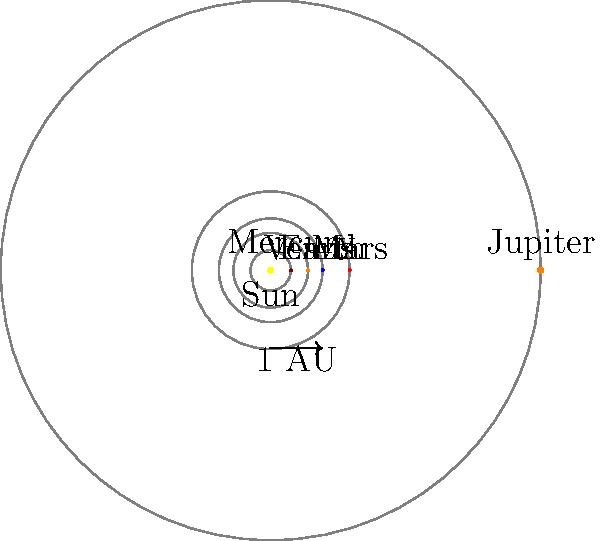Given your expertise in cancer research and data analysis, consider the following astronomical question:

The diagram shows a simplified model of the inner Solar System and Jupiter. If the average orbital radius of Earth is defined as 1 Astronomical Unit (AU), what is the approximate orbital radius of Jupiter in AU, and how does this relate to the concept of "zones" in the Solar System? To answer this question, we'll follow these steps:

1. Analyze the diagram:
   - The orbits are represented by concentric circles.
   - Earth's orbit is labeled and defined as 1 AU.
   - Jupiter's orbit is the outermost circle shown.

2. Estimate Jupiter's orbital radius:
   - Using the scale provided (1 AU), we can visually estimate that Jupiter's orbit is about 5 times larger than Earth's.
   - The actual value, which is close to our estimate, is 5.2 AU.

3. Understand the concept of "zones" in the Solar System:
   - The Solar System is often divided into two main zones: the inner and outer Solar System.
   - The inner Solar System contains the terrestrial planets: Mercury, Venus, Earth, and Mars.
   - The outer Solar System begins with the asteroid belt and includes the gas giants.

4. Relate Jupiter's position to these zones:
   - Jupiter is the first planet of the outer Solar System.
   - Its large orbital radius (5.2 AU) places it well beyond the terrestrial planets.
   - This significant distance correlates with the different composition and characteristics of inner and outer planets.

5. Connect to research methodologies:
   - In cancer research, we often categorize data into distinct groups or zones based on specific characteristics.
   - Similarly, in astronomy, the division of the Solar System into zones helps in understanding the formation and evolution of different types of planets.

The large orbital radius of Jupiter (5.2 AU) marks the transition from the inner to the outer Solar System, analogous to how we might distinguish between different stages or types of cancer in our research.
Answer: 5.2 AU; marks inner-outer Solar System boundary 